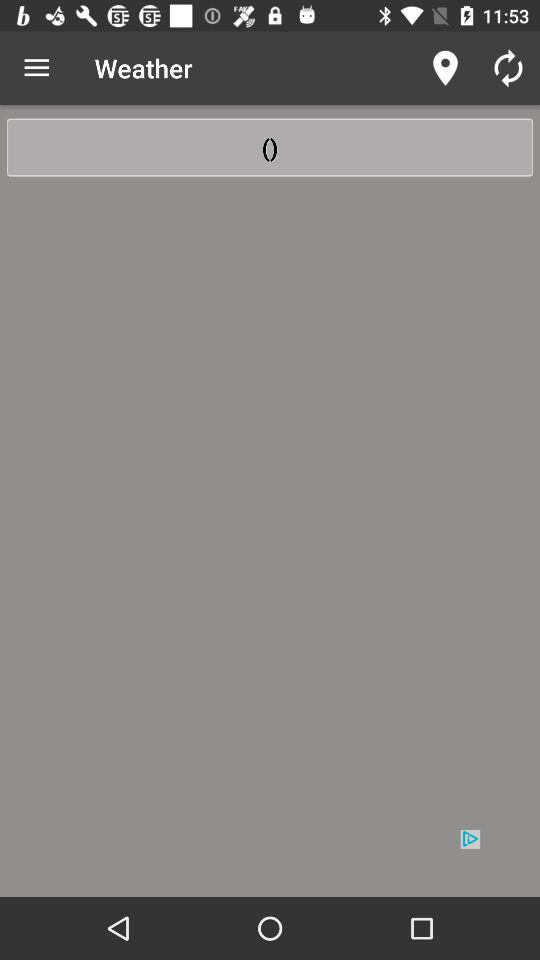What is the application name? The application name is "Weather". 